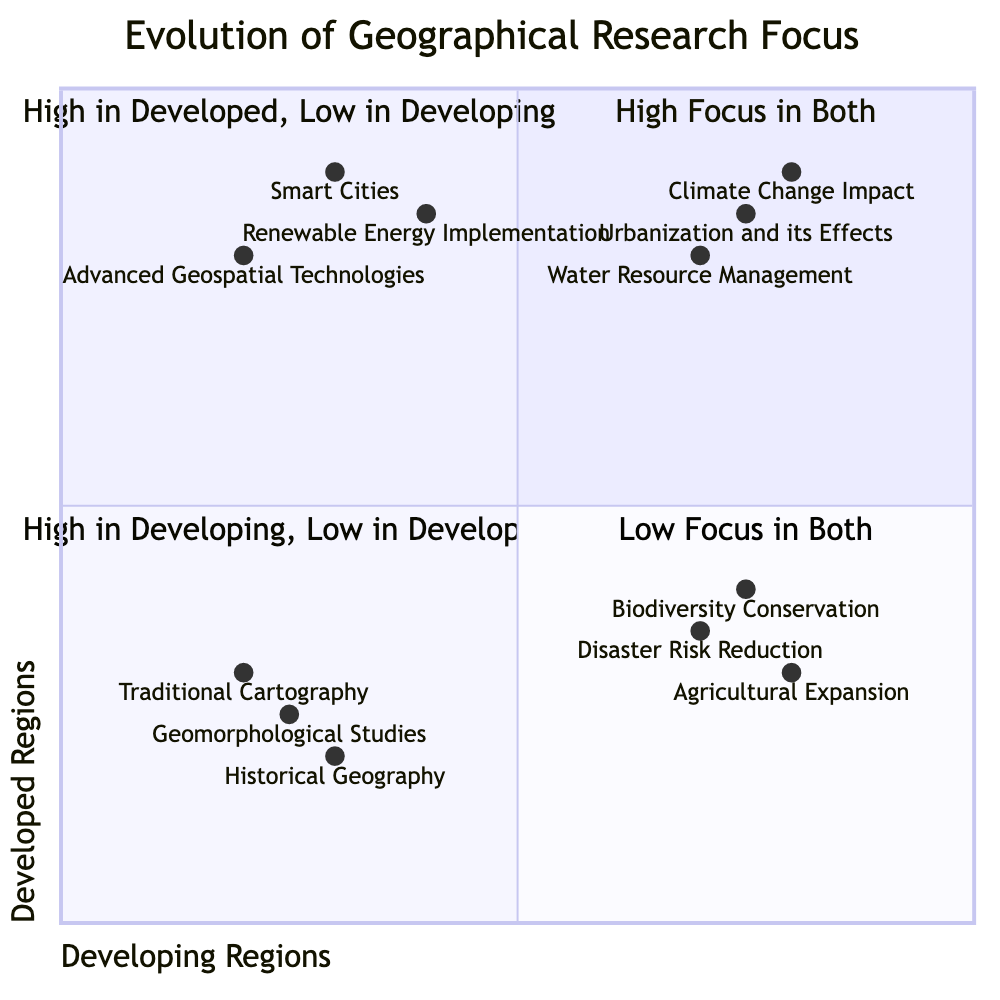What topics are in Quadrant 1? Quadrant 1 contains topics that have a high research focus in both developing and developed regions. The listed topics are "Climate Change Impact," "Urbanization and its Effects," and "Water Resource Management."
Answer: Climate Change Impact, Urbanization and its Effects, Water Resource Management Which quadrant has a high research focus in developed regions but low in developing regions? The quadrant with a high research focus in developed regions and low in developing regions is Quadrant 2. This quadrant includes topics that are advanced or technology-driven.
Answer: Quadrant 2 What is the research focus of "Agricultural Expansion"? "Agricultural Expansion" is primarily focused in developing regions, as indicated by its position in Quadrant 3, where there is high focus in developing regions and low focus in developed regions.
Answer: Developing Regions How many topics are listed in Quadrant 4? Quadrant 4 is characterized by low research focus in both regions and includes three topics: "Traditional Cartography," "Historical Geography," and "Geomorphological Studies." Therefore, there are three topics in this quadrant.
Answer: 3 Which topic has the highest focus in developed regions according to the chart? The topic with the highest focus in developed regions is "Smart Cities," as it has a coordinate value close to 1 on the y-axis at approximately 0.9, indicating strong emphasis.
Answer: Smart Cities Where does "Disaster Risk Reduction" fall in the quadrants? "Disaster Risk Reduction" is located in Quadrant 3, which signifies high research focus in developing regions and low focus in developed regions.
Answer: Quadrant 3 Which quadrant addresses both Developing and Developed Regions with significant research topics? Quadrant 1 addresses both developing and developed regions with significant research topics, displaying a high focus.
Answer: Quadrant 1 What is the general trend for research topics in traditionally low-focus areas? The general trend in Quadrant 4 reflects low research focus areas on topics such as "Traditional Cartography," "Historical Geography," and "Geomorphological Studies," indicating a lack of research emphasis over the years in both regions.
Answer: Low Focus 